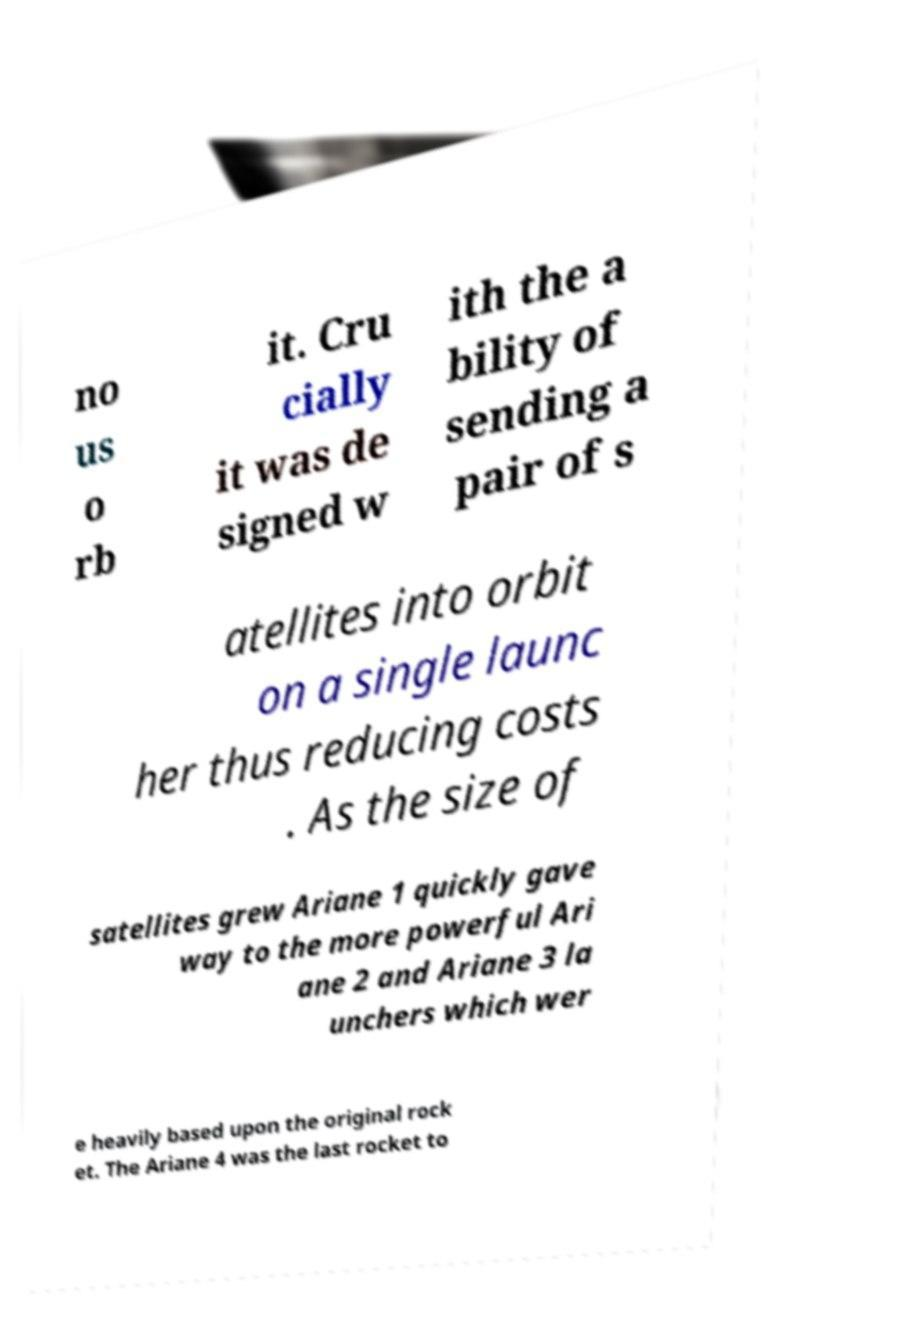I need the written content from this picture converted into text. Can you do that? no us o rb it. Cru cially it was de signed w ith the a bility of sending a pair of s atellites into orbit on a single launc her thus reducing costs . As the size of satellites grew Ariane 1 quickly gave way to the more powerful Ari ane 2 and Ariane 3 la unchers which wer e heavily based upon the original rock et. The Ariane 4 was the last rocket to 